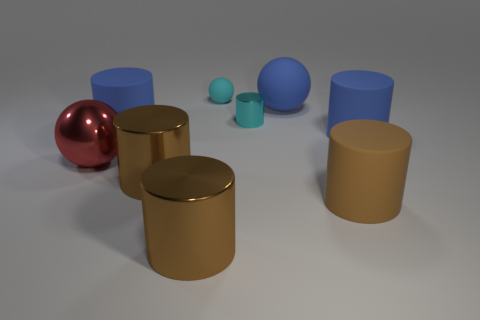Are there any other cyan metal cylinders that have the same size as the cyan cylinder?
Your answer should be very brief. No. What number of things are either objects on the right side of the tiny cyan rubber thing or big blue cylinders right of the tiny metallic cylinder?
Your answer should be compact. 4. There is a blue cylinder that is on the left side of the cyan shiny object; is it the same size as the cyan object that is in front of the small sphere?
Make the answer very short. No. There is a small cyan thing on the left side of the small cylinder; are there any metallic cylinders that are right of it?
Your response must be concise. Yes. What number of big objects are right of the red shiny object?
Offer a very short reply. 6. How many other objects are the same color as the big metallic ball?
Provide a short and direct response. 0. Is the number of red things on the right side of the large matte sphere less than the number of tiny cyan rubber balls behind the red metallic sphere?
Offer a very short reply. Yes. What number of objects are large cylinders that are behind the red shiny object or cyan things?
Keep it short and to the point. 4. Is the size of the cyan matte ball the same as the blue matte cylinder to the left of the small cyan shiny cylinder?
Provide a succinct answer. No. What is the size of the other matte thing that is the same shape as the tiny matte thing?
Offer a terse response. Large. 